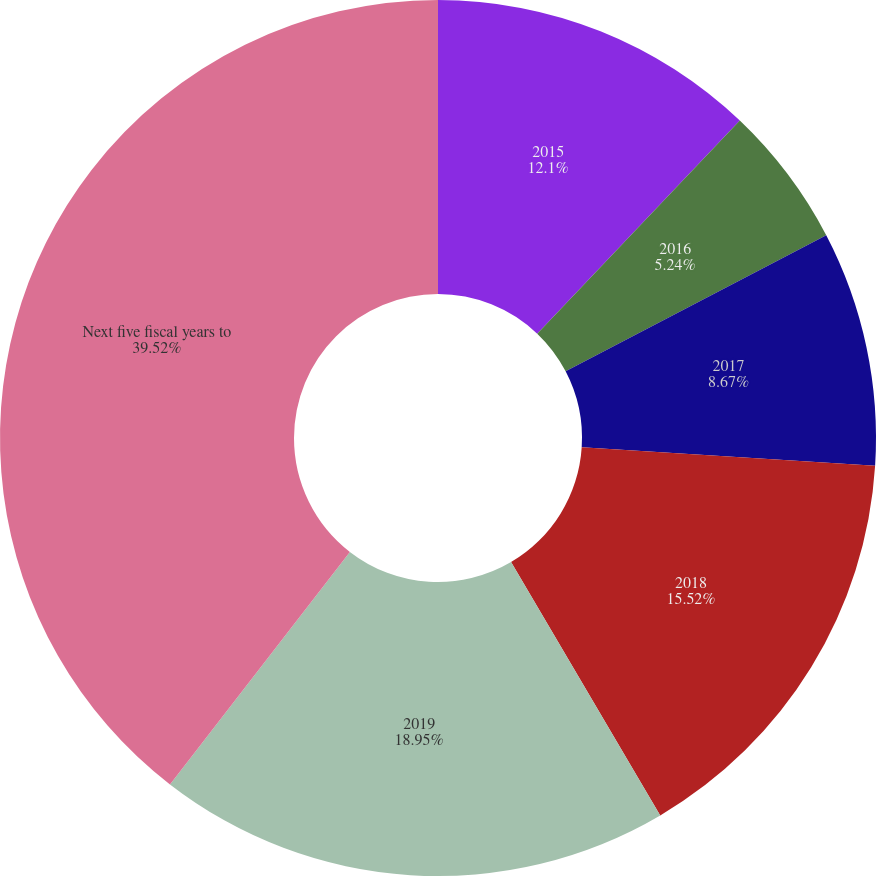Convert chart to OTSL. <chart><loc_0><loc_0><loc_500><loc_500><pie_chart><fcel>2015<fcel>2016<fcel>2017<fcel>2018<fcel>2019<fcel>Next five fiscal years to<nl><fcel>12.1%<fcel>5.24%<fcel>8.67%<fcel>15.52%<fcel>18.95%<fcel>39.52%<nl></chart> 